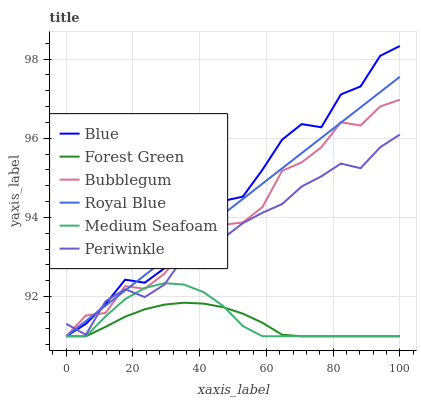Does Forest Green have the minimum area under the curve?
Answer yes or no. Yes. Does Blue have the maximum area under the curve?
Answer yes or no. Yes. Does Bubblegum have the minimum area under the curve?
Answer yes or no. No. Does Bubblegum have the maximum area under the curve?
Answer yes or no. No. Is Royal Blue the smoothest?
Answer yes or no. Yes. Is Blue the roughest?
Answer yes or no. Yes. Is Bubblegum the smoothest?
Answer yes or no. No. Is Bubblegum the roughest?
Answer yes or no. No. Does Blue have the lowest value?
Answer yes or no. Yes. Does Periwinkle have the lowest value?
Answer yes or no. No. Does Blue have the highest value?
Answer yes or no. Yes. Does Bubblegum have the highest value?
Answer yes or no. No. Is Forest Green less than Periwinkle?
Answer yes or no. Yes. Is Periwinkle greater than Forest Green?
Answer yes or no. Yes. Does Bubblegum intersect Forest Green?
Answer yes or no. Yes. Is Bubblegum less than Forest Green?
Answer yes or no. No. Is Bubblegum greater than Forest Green?
Answer yes or no. No. Does Forest Green intersect Periwinkle?
Answer yes or no. No. 